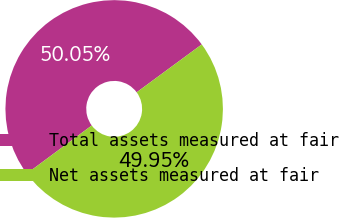Convert chart to OTSL. <chart><loc_0><loc_0><loc_500><loc_500><pie_chart><fcel>Total assets measured at fair<fcel>Net assets measured at fair<nl><fcel>50.05%<fcel>49.95%<nl></chart> 